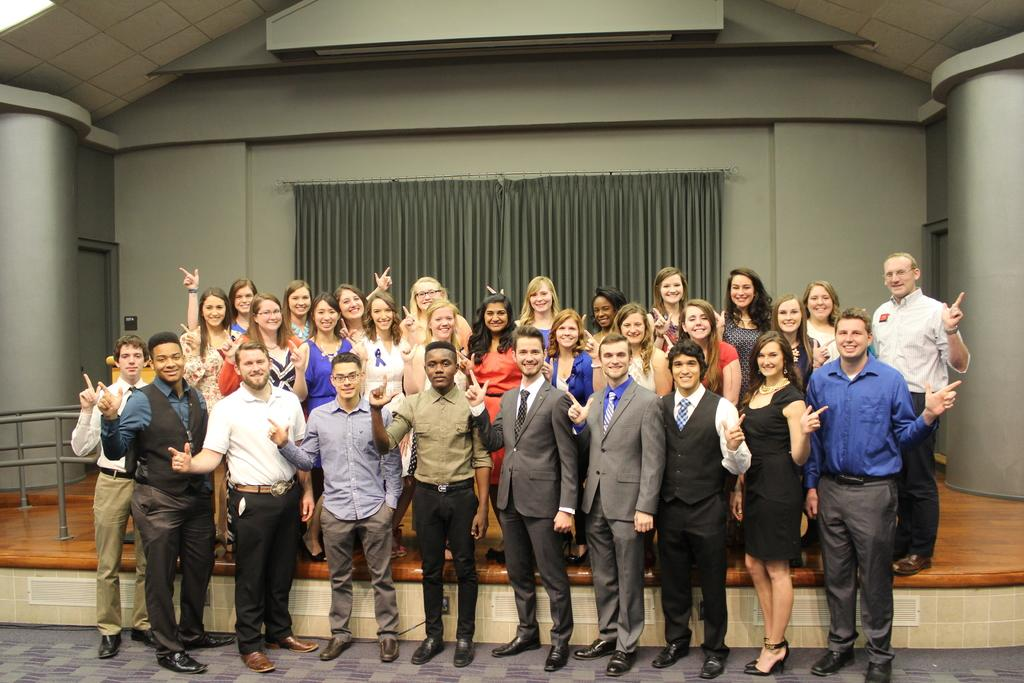What is the main subject of the image? The main subject of the image is a group of people. Where are the people located in the image? The people are standing on the floor. What is the facial expression of the people in the image? All the people in the group are smiling. What can be seen in the background of the image? There is a curtain in the background of the image. What type of bridge can be seen in the image? There is no bridge present in the image. How is the group of people divided in the image? The group of people is not divided in the image; they are all standing together. 